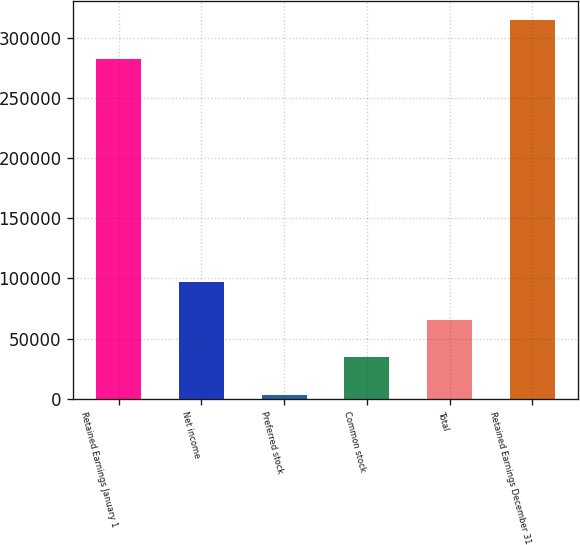Convert chart. <chart><loc_0><loc_0><loc_500><loc_500><bar_chart><fcel>Retained Earnings January 1<fcel>Net income<fcel>Preferred stock<fcel>Common stock<fcel>Total<fcel>Retained Earnings December 31<nl><fcel>282847<fcel>96809.1<fcel>3369<fcel>34515.7<fcel>65662.4<fcel>314836<nl></chart> 